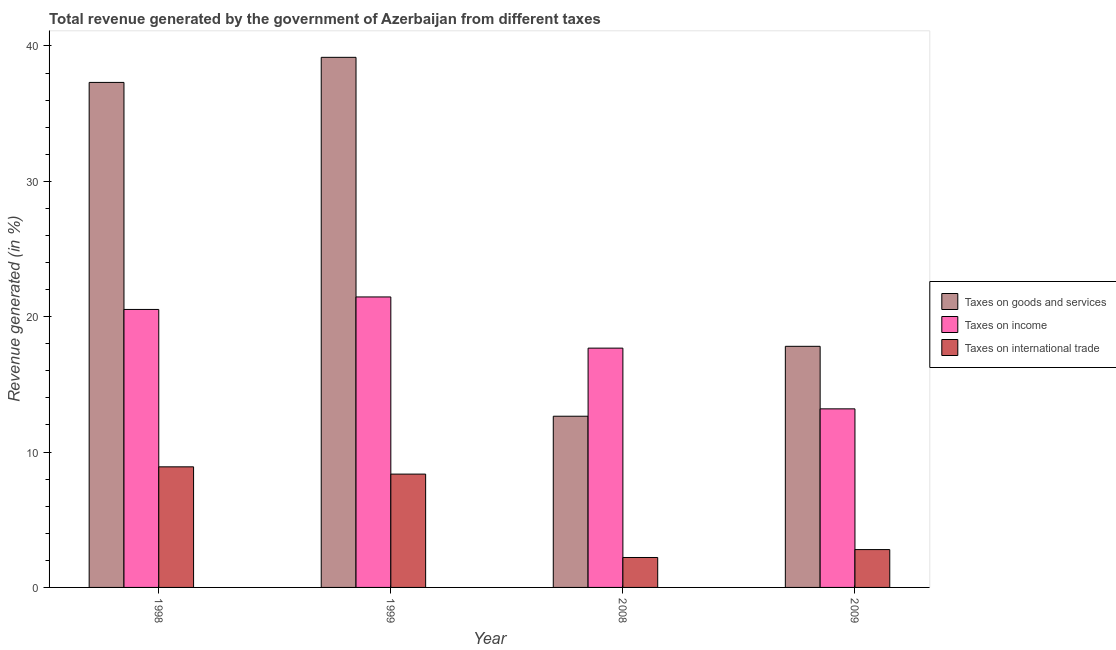How many groups of bars are there?
Ensure brevity in your answer.  4. How many bars are there on the 3rd tick from the left?
Your answer should be very brief. 3. What is the label of the 2nd group of bars from the left?
Offer a terse response. 1999. What is the percentage of revenue generated by tax on international trade in 1999?
Make the answer very short. 8.37. Across all years, what is the maximum percentage of revenue generated by taxes on income?
Keep it short and to the point. 21.46. Across all years, what is the minimum percentage of revenue generated by taxes on income?
Offer a very short reply. 13.19. In which year was the percentage of revenue generated by taxes on income maximum?
Offer a terse response. 1999. What is the total percentage of revenue generated by tax on international trade in the graph?
Your response must be concise. 22.29. What is the difference between the percentage of revenue generated by taxes on income in 1998 and that in 2008?
Keep it short and to the point. 2.86. What is the difference between the percentage of revenue generated by taxes on goods and services in 1999 and the percentage of revenue generated by taxes on income in 1998?
Your response must be concise. 1.85. What is the average percentage of revenue generated by taxes on income per year?
Ensure brevity in your answer.  18.22. What is the ratio of the percentage of revenue generated by taxes on income in 1999 to that in 2009?
Make the answer very short. 1.63. What is the difference between the highest and the second highest percentage of revenue generated by taxes on goods and services?
Provide a succinct answer. 1.85. What is the difference between the highest and the lowest percentage of revenue generated by tax on international trade?
Your answer should be very brief. 6.7. What does the 3rd bar from the left in 1998 represents?
Offer a terse response. Taxes on international trade. What does the 1st bar from the right in 2008 represents?
Ensure brevity in your answer.  Taxes on international trade. Is it the case that in every year, the sum of the percentage of revenue generated by taxes on goods and services and percentage of revenue generated by taxes on income is greater than the percentage of revenue generated by tax on international trade?
Provide a succinct answer. Yes. How many years are there in the graph?
Ensure brevity in your answer.  4. What is the difference between two consecutive major ticks on the Y-axis?
Give a very brief answer. 10. Are the values on the major ticks of Y-axis written in scientific E-notation?
Make the answer very short. No. What is the title of the graph?
Provide a short and direct response. Total revenue generated by the government of Azerbaijan from different taxes. Does "Coal sources" appear as one of the legend labels in the graph?
Keep it short and to the point. No. What is the label or title of the X-axis?
Keep it short and to the point. Year. What is the label or title of the Y-axis?
Your answer should be very brief. Revenue generated (in %). What is the Revenue generated (in %) in Taxes on goods and services in 1998?
Keep it short and to the point. 37.31. What is the Revenue generated (in %) of Taxes on income in 1998?
Keep it short and to the point. 20.54. What is the Revenue generated (in %) of Taxes on international trade in 1998?
Offer a terse response. 8.91. What is the Revenue generated (in %) of Taxes on goods and services in 1999?
Your answer should be compact. 39.16. What is the Revenue generated (in %) of Taxes on income in 1999?
Offer a very short reply. 21.46. What is the Revenue generated (in %) of Taxes on international trade in 1999?
Offer a very short reply. 8.37. What is the Revenue generated (in %) in Taxes on goods and services in 2008?
Your answer should be compact. 12.65. What is the Revenue generated (in %) of Taxes on income in 2008?
Offer a terse response. 17.68. What is the Revenue generated (in %) of Taxes on international trade in 2008?
Keep it short and to the point. 2.21. What is the Revenue generated (in %) in Taxes on goods and services in 2009?
Provide a short and direct response. 17.81. What is the Revenue generated (in %) in Taxes on income in 2009?
Give a very brief answer. 13.19. What is the Revenue generated (in %) in Taxes on international trade in 2009?
Keep it short and to the point. 2.8. Across all years, what is the maximum Revenue generated (in %) of Taxes on goods and services?
Ensure brevity in your answer.  39.16. Across all years, what is the maximum Revenue generated (in %) in Taxes on income?
Provide a succinct answer. 21.46. Across all years, what is the maximum Revenue generated (in %) in Taxes on international trade?
Your response must be concise. 8.91. Across all years, what is the minimum Revenue generated (in %) in Taxes on goods and services?
Provide a succinct answer. 12.65. Across all years, what is the minimum Revenue generated (in %) of Taxes on income?
Your answer should be very brief. 13.19. Across all years, what is the minimum Revenue generated (in %) of Taxes on international trade?
Provide a succinct answer. 2.21. What is the total Revenue generated (in %) in Taxes on goods and services in the graph?
Keep it short and to the point. 106.93. What is the total Revenue generated (in %) in Taxes on income in the graph?
Offer a very short reply. 72.87. What is the total Revenue generated (in %) of Taxes on international trade in the graph?
Your answer should be compact. 22.29. What is the difference between the Revenue generated (in %) in Taxes on goods and services in 1998 and that in 1999?
Offer a terse response. -1.85. What is the difference between the Revenue generated (in %) of Taxes on income in 1998 and that in 1999?
Ensure brevity in your answer.  -0.92. What is the difference between the Revenue generated (in %) of Taxes on international trade in 1998 and that in 1999?
Give a very brief answer. 0.54. What is the difference between the Revenue generated (in %) of Taxes on goods and services in 1998 and that in 2008?
Your response must be concise. 24.66. What is the difference between the Revenue generated (in %) in Taxes on income in 1998 and that in 2008?
Provide a short and direct response. 2.86. What is the difference between the Revenue generated (in %) in Taxes on international trade in 1998 and that in 2008?
Provide a succinct answer. 6.7. What is the difference between the Revenue generated (in %) of Taxes on goods and services in 1998 and that in 2009?
Provide a succinct answer. 19.5. What is the difference between the Revenue generated (in %) in Taxes on income in 1998 and that in 2009?
Provide a short and direct response. 7.34. What is the difference between the Revenue generated (in %) of Taxes on international trade in 1998 and that in 2009?
Offer a terse response. 6.11. What is the difference between the Revenue generated (in %) of Taxes on goods and services in 1999 and that in 2008?
Ensure brevity in your answer.  26.52. What is the difference between the Revenue generated (in %) in Taxes on income in 1999 and that in 2008?
Offer a terse response. 3.78. What is the difference between the Revenue generated (in %) of Taxes on international trade in 1999 and that in 2008?
Keep it short and to the point. 6.16. What is the difference between the Revenue generated (in %) in Taxes on goods and services in 1999 and that in 2009?
Provide a succinct answer. 21.35. What is the difference between the Revenue generated (in %) in Taxes on income in 1999 and that in 2009?
Your response must be concise. 8.27. What is the difference between the Revenue generated (in %) in Taxes on international trade in 1999 and that in 2009?
Ensure brevity in your answer.  5.58. What is the difference between the Revenue generated (in %) of Taxes on goods and services in 2008 and that in 2009?
Your answer should be very brief. -5.16. What is the difference between the Revenue generated (in %) in Taxes on income in 2008 and that in 2009?
Provide a short and direct response. 4.49. What is the difference between the Revenue generated (in %) of Taxes on international trade in 2008 and that in 2009?
Give a very brief answer. -0.58. What is the difference between the Revenue generated (in %) in Taxes on goods and services in 1998 and the Revenue generated (in %) in Taxes on income in 1999?
Provide a succinct answer. 15.85. What is the difference between the Revenue generated (in %) in Taxes on goods and services in 1998 and the Revenue generated (in %) in Taxes on international trade in 1999?
Your response must be concise. 28.94. What is the difference between the Revenue generated (in %) in Taxes on income in 1998 and the Revenue generated (in %) in Taxes on international trade in 1999?
Ensure brevity in your answer.  12.16. What is the difference between the Revenue generated (in %) in Taxes on goods and services in 1998 and the Revenue generated (in %) in Taxes on income in 2008?
Your response must be concise. 19.63. What is the difference between the Revenue generated (in %) in Taxes on goods and services in 1998 and the Revenue generated (in %) in Taxes on international trade in 2008?
Offer a terse response. 35.1. What is the difference between the Revenue generated (in %) of Taxes on income in 1998 and the Revenue generated (in %) of Taxes on international trade in 2008?
Provide a short and direct response. 18.33. What is the difference between the Revenue generated (in %) of Taxes on goods and services in 1998 and the Revenue generated (in %) of Taxes on income in 2009?
Offer a very short reply. 24.12. What is the difference between the Revenue generated (in %) of Taxes on goods and services in 1998 and the Revenue generated (in %) of Taxes on international trade in 2009?
Offer a terse response. 34.51. What is the difference between the Revenue generated (in %) in Taxes on income in 1998 and the Revenue generated (in %) in Taxes on international trade in 2009?
Ensure brevity in your answer.  17.74. What is the difference between the Revenue generated (in %) of Taxes on goods and services in 1999 and the Revenue generated (in %) of Taxes on income in 2008?
Give a very brief answer. 21.48. What is the difference between the Revenue generated (in %) in Taxes on goods and services in 1999 and the Revenue generated (in %) in Taxes on international trade in 2008?
Ensure brevity in your answer.  36.95. What is the difference between the Revenue generated (in %) of Taxes on income in 1999 and the Revenue generated (in %) of Taxes on international trade in 2008?
Offer a very short reply. 19.25. What is the difference between the Revenue generated (in %) of Taxes on goods and services in 1999 and the Revenue generated (in %) of Taxes on income in 2009?
Provide a short and direct response. 25.97. What is the difference between the Revenue generated (in %) of Taxes on goods and services in 1999 and the Revenue generated (in %) of Taxes on international trade in 2009?
Provide a succinct answer. 36.37. What is the difference between the Revenue generated (in %) in Taxes on income in 1999 and the Revenue generated (in %) in Taxes on international trade in 2009?
Make the answer very short. 18.67. What is the difference between the Revenue generated (in %) of Taxes on goods and services in 2008 and the Revenue generated (in %) of Taxes on income in 2009?
Provide a short and direct response. -0.54. What is the difference between the Revenue generated (in %) in Taxes on goods and services in 2008 and the Revenue generated (in %) in Taxes on international trade in 2009?
Your answer should be very brief. 9.85. What is the difference between the Revenue generated (in %) of Taxes on income in 2008 and the Revenue generated (in %) of Taxes on international trade in 2009?
Your answer should be compact. 14.88. What is the average Revenue generated (in %) of Taxes on goods and services per year?
Provide a succinct answer. 26.73. What is the average Revenue generated (in %) in Taxes on income per year?
Provide a short and direct response. 18.22. What is the average Revenue generated (in %) in Taxes on international trade per year?
Provide a succinct answer. 5.57. In the year 1998, what is the difference between the Revenue generated (in %) of Taxes on goods and services and Revenue generated (in %) of Taxes on income?
Offer a terse response. 16.77. In the year 1998, what is the difference between the Revenue generated (in %) in Taxes on goods and services and Revenue generated (in %) in Taxes on international trade?
Provide a short and direct response. 28.4. In the year 1998, what is the difference between the Revenue generated (in %) in Taxes on income and Revenue generated (in %) in Taxes on international trade?
Your answer should be compact. 11.63. In the year 1999, what is the difference between the Revenue generated (in %) of Taxes on goods and services and Revenue generated (in %) of Taxes on income?
Give a very brief answer. 17.7. In the year 1999, what is the difference between the Revenue generated (in %) of Taxes on goods and services and Revenue generated (in %) of Taxes on international trade?
Ensure brevity in your answer.  30.79. In the year 1999, what is the difference between the Revenue generated (in %) of Taxes on income and Revenue generated (in %) of Taxes on international trade?
Offer a terse response. 13.09. In the year 2008, what is the difference between the Revenue generated (in %) in Taxes on goods and services and Revenue generated (in %) in Taxes on income?
Provide a succinct answer. -5.03. In the year 2008, what is the difference between the Revenue generated (in %) of Taxes on goods and services and Revenue generated (in %) of Taxes on international trade?
Keep it short and to the point. 10.44. In the year 2008, what is the difference between the Revenue generated (in %) of Taxes on income and Revenue generated (in %) of Taxes on international trade?
Your answer should be very brief. 15.47. In the year 2009, what is the difference between the Revenue generated (in %) in Taxes on goods and services and Revenue generated (in %) in Taxes on income?
Your response must be concise. 4.62. In the year 2009, what is the difference between the Revenue generated (in %) in Taxes on goods and services and Revenue generated (in %) in Taxes on international trade?
Give a very brief answer. 15.02. In the year 2009, what is the difference between the Revenue generated (in %) in Taxes on income and Revenue generated (in %) in Taxes on international trade?
Offer a very short reply. 10.4. What is the ratio of the Revenue generated (in %) of Taxes on goods and services in 1998 to that in 1999?
Offer a terse response. 0.95. What is the ratio of the Revenue generated (in %) of Taxes on income in 1998 to that in 1999?
Provide a succinct answer. 0.96. What is the ratio of the Revenue generated (in %) of Taxes on international trade in 1998 to that in 1999?
Offer a terse response. 1.06. What is the ratio of the Revenue generated (in %) in Taxes on goods and services in 1998 to that in 2008?
Keep it short and to the point. 2.95. What is the ratio of the Revenue generated (in %) in Taxes on income in 1998 to that in 2008?
Offer a terse response. 1.16. What is the ratio of the Revenue generated (in %) in Taxes on international trade in 1998 to that in 2008?
Your answer should be compact. 4.03. What is the ratio of the Revenue generated (in %) in Taxes on goods and services in 1998 to that in 2009?
Your response must be concise. 2.09. What is the ratio of the Revenue generated (in %) of Taxes on income in 1998 to that in 2009?
Provide a short and direct response. 1.56. What is the ratio of the Revenue generated (in %) in Taxes on international trade in 1998 to that in 2009?
Keep it short and to the point. 3.19. What is the ratio of the Revenue generated (in %) of Taxes on goods and services in 1999 to that in 2008?
Provide a succinct answer. 3.1. What is the ratio of the Revenue generated (in %) in Taxes on income in 1999 to that in 2008?
Offer a very short reply. 1.21. What is the ratio of the Revenue generated (in %) of Taxes on international trade in 1999 to that in 2008?
Offer a terse response. 3.79. What is the ratio of the Revenue generated (in %) of Taxes on goods and services in 1999 to that in 2009?
Your answer should be compact. 2.2. What is the ratio of the Revenue generated (in %) in Taxes on income in 1999 to that in 2009?
Provide a short and direct response. 1.63. What is the ratio of the Revenue generated (in %) of Taxes on international trade in 1999 to that in 2009?
Give a very brief answer. 2.99. What is the ratio of the Revenue generated (in %) of Taxes on goods and services in 2008 to that in 2009?
Provide a succinct answer. 0.71. What is the ratio of the Revenue generated (in %) of Taxes on income in 2008 to that in 2009?
Make the answer very short. 1.34. What is the ratio of the Revenue generated (in %) in Taxes on international trade in 2008 to that in 2009?
Offer a terse response. 0.79. What is the difference between the highest and the second highest Revenue generated (in %) of Taxes on goods and services?
Give a very brief answer. 1.85. What is the difference between the highest and the second highest Revenue generated (in %) in Taxes on income?
Your answer should be compact. 0.92. What is the difference between the highest and the second highest Revenue generated (in %) in Taxes on international trade?
Your response must be concise. 0.54. What is the difference between the highest and the lowest Revenue generated (in %) in Taxes on goods and services?
Ensure brevity in your answer.  26.52. What is the difference between the highest and the lowest Revenue generated (in %) in Taxes on income?
Your answer should be compact. 8.27. What is the difference between the highest and the lowest Revenue generated (in %) of Taxes on international trade?
Your answer should be compact. 6.7. 